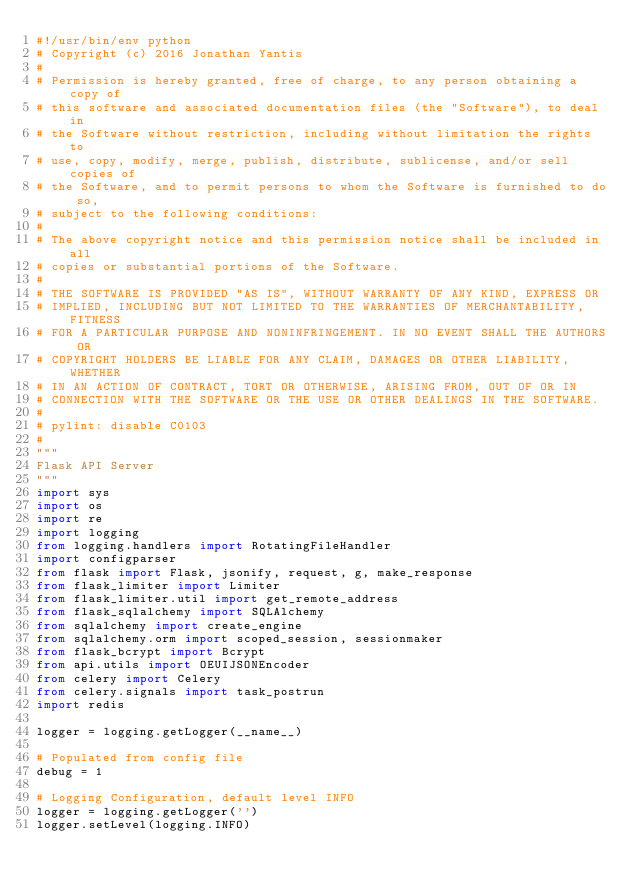Convert code to text. <code><loc_0><loc_0><loc_500><loc_500><_Python_>#!/usr/bin/env python
# Copyright (c) 2016 Jonathan Yantis
#
# Permission is hereby granted, free of charge, to any person obtaining a copy of
# this software and associated documentation files (the "Software"), to deal in
# the Software without restriction, including without limitation the rights to
# use, copy, modify, merge, publish, distribute, sublicense, and/or sell copies of
# the Software, and to permit persons to whom the Software is furnished to do so,
# subject to the following conditions:
#
# The above copyright notice and this permission notice shall be included in all
# copies or substantial portions of the Software.
#
# THE SOFTWARE IS PROVIDED "AS IS", WITHOUT WARRANTY OF ANY KIND, EXPRESS OR
# IMPLIED, INCLUDING BUT NOT LIMITED TO THE WARRANTIES OF MERCHANTABILITY, FITNESS
# FOR A PARTICULAR PURPOSE AND NONINFRINGEMENT. IN NO EVENT SHALL THE AUTHORS OR
# COPYRIGHT HOLDERS BE LIABLE FOR ANY CLAIM, DAMAGES OR OTHER LIABILITY, WHETHER
# IN AN ACTION OF CONTRACT, TORT OR OTHERWISE, ARISING FROM, OUT OF OR IN
# CONNECTION WITH THE SOFTWARE OR THE USE OR OTHER DEALINGS IN THE SOFTWARE.
#
# pylint: disable C0103
#
"""
Flask API Server
"""
import sys
import os
import re
import logging
from logging.handlers import RotatingFileHandler
import configparser
from flask import Flask, jsonify, request, g, make_response
from flask_limiter import Limiter
from flask_limiter.util import get_remote_address
from flask_sqlalchemy import SQLAlchemy
from sqlalchemy import create_engine
from sqlalchemy.orm import scoped_session, sessionmaker
from flask_bcrypt import Bcrypt
from api.utils import OEUIJSONEncoder
from celery import Celery
from celery.signals import task_postrun
import redis

logger = logging.getLogger(__name__)

# Populated from config file
debug = 1

# Logging Configuration, default level INFO
logger = logging.getLogger('')
logger.setLevel(logging.INFO)</code> 